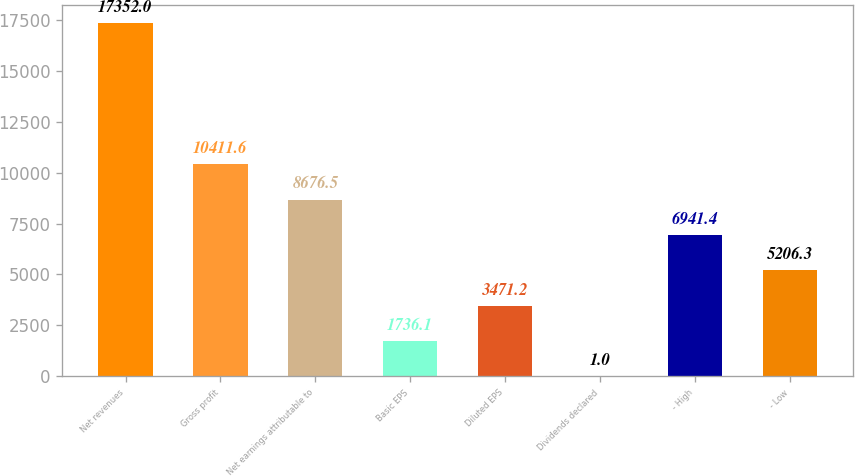Convert chart to OTSL. <chart><loc_0><loc_0><loc_500><loc_500><bar_chart><fcel>Net revenues<fcel>Gross profit<fcel>Net earnings attributable to<fcel>Basic EPS<fcel>Diluted EPS<fcel>Dividends declared<fcel>- High<fcel>- Low<nl><fcel>17352<fcel>10411.6<fcel>8676.5<fcel>1736.1<fcel>3471.2<fcel>1<fcel>6941.4<fcel>5206.3<nl></chart> 